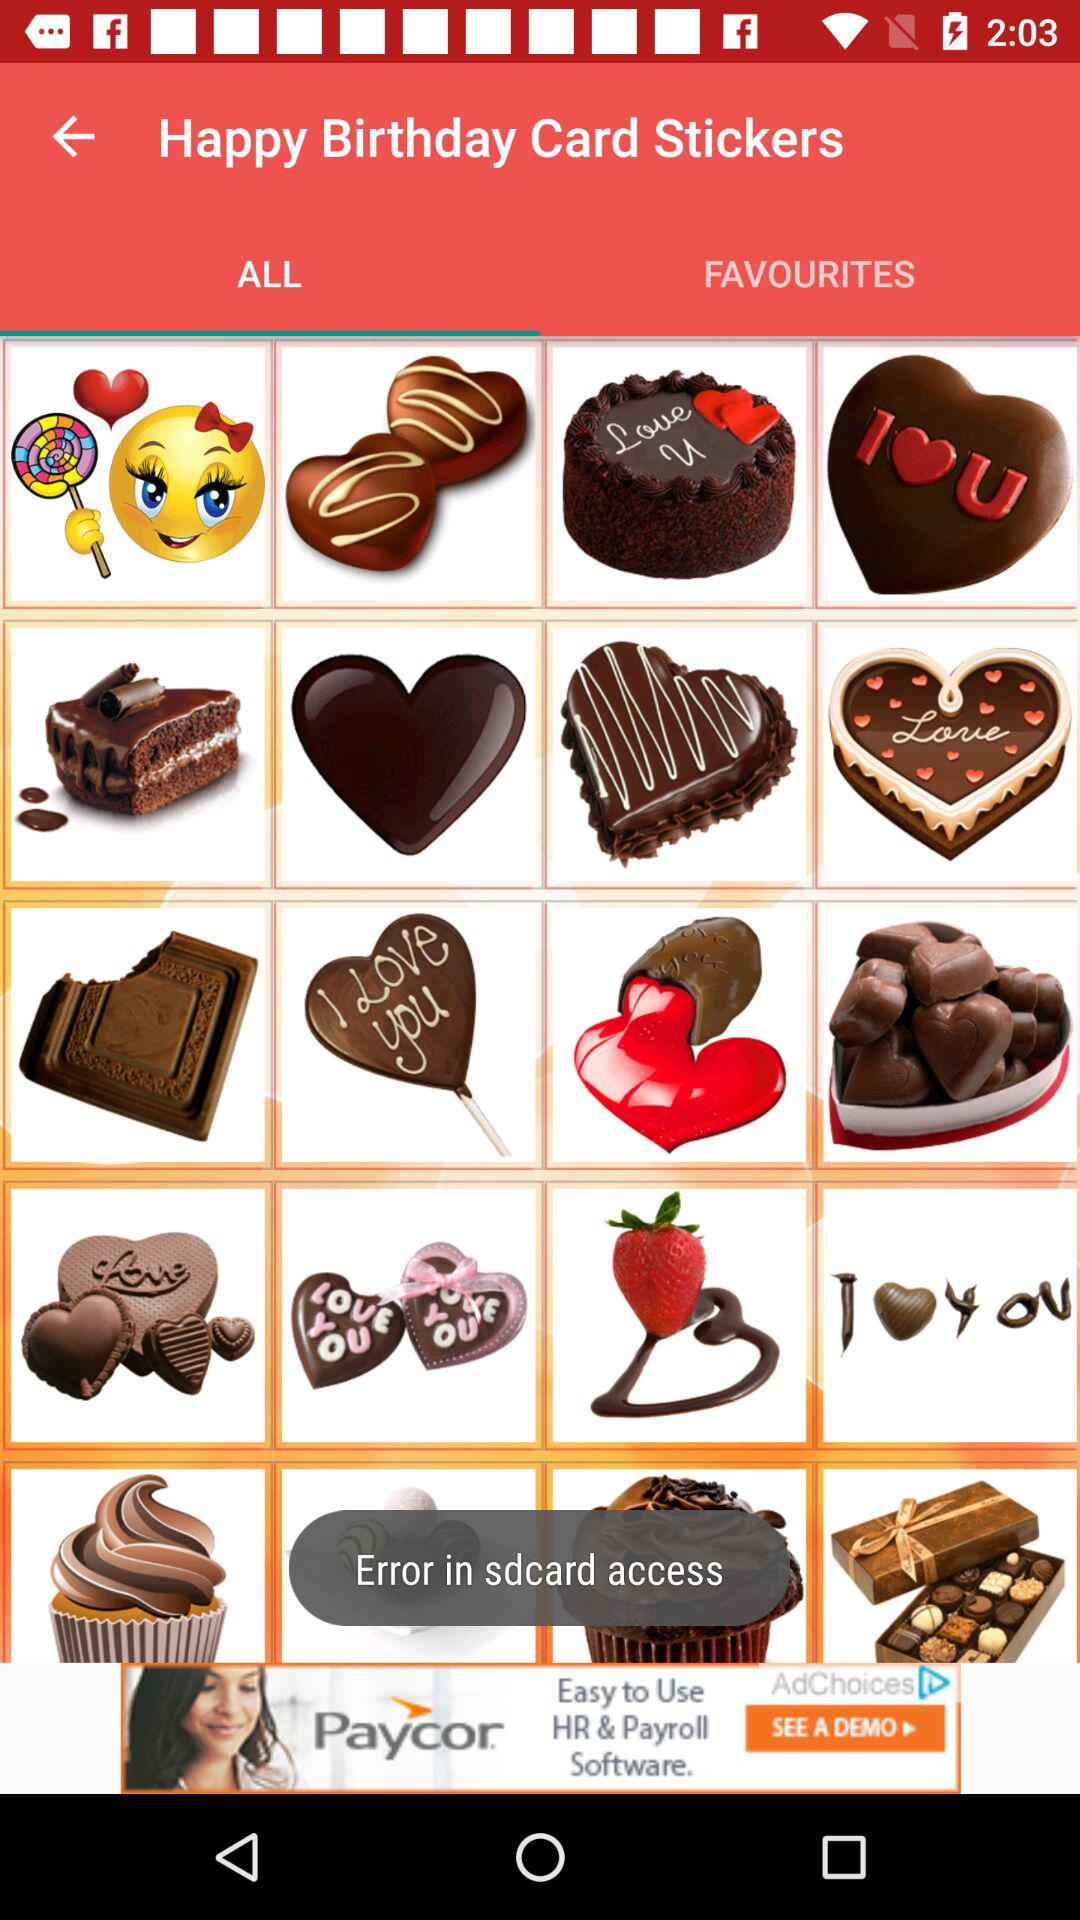What is the selected tab? The selected tab is "ALL". 